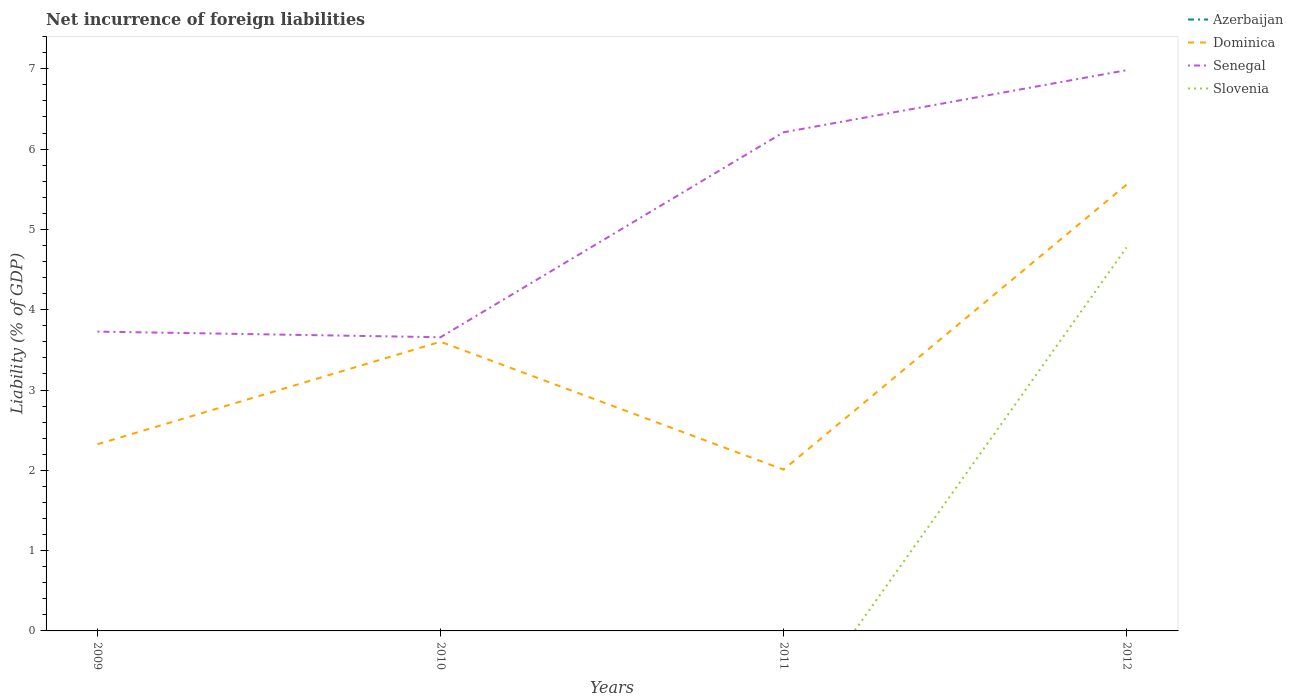Across all years, what is the maximum net incurrence of foreign liabilities in Senegal?
Ensure brevity in your answer.  3.66. What is the total net incurrence of foreign liabilities in Senegal in the graph?
Give a very brief answer. -2.55. What is the difference between the highest and the second highest net incurrence of foreign liabilities in Dominica?
Offer a terse response. 3.55. What is the difference between the highest and the lowest net incurrence of foreign liabilities in Azerbaijan?
Keep it short and to the point. 0. How many years are there in the graph?
Your answer should be very brief. 4. What is the difference between two consecutive major ticks on the Y-axis?
Provide a short and direct response. 1. Are the values on the major ticks of Y-axis written in scientific E-notation?
Ensure brevity in your answer.  No. Does the graph contain grids?
Make the answer very short. No. What is the title of the graph?
Ensure brevity in your answer.  Net incurrence of foreign liabilities. What is the label or title of the Y-axis?
Give a very brief answer. Liability (% of GDP). What is the Liability (% of GDP) in Azerbaijan in 2009?
Offer a very short reply. 0. What is the Liability (% of GDP) in Dominica in 2009?
Provide a succinct answer. 2.32. What is the Liability (% of GDP) in Senegal in 2009?
Provide a short and direct response. 3.73. What is the Liability (% of GDP) of Slovenia in 2009?
Offer a very short reply. 0. What is the Liability (% of GDP) of Dominica in 2010?
Keep it short and to the point. 3.6. What is the Liability (% of GDP) of Senegal in 2010?
Offer a terse response. 3.66. What is the Liability (% of GDP) of Azerbaijan in 2011?
Offer a terse response. 0. What is the Liability (% of GDP) in Dominica in 2011?
Provide a succinct answer. 2.01. What is the Liability (% of GDP) of Senegal in 2011?
Offer a very short reply. 6.21. What is the Liability (% of GDP) in Slovenia in 2011?
Provide a succinct answer. 0. What is the Liability (% of GDP) in Dominica in 2012?
Provide a succinct answer. 5.56. What is the Liability (% of GDP) in Senegal in 2012?
Your answer should be compact. 6.98. What is the Liability (% of GDP) in Slovenia in 2012?
Give a very brief answer. 4.78. Across all years, what is the maximum Liability (% of GDP) in Dominica?
Ensure brevity in your answer.  5.56. Across all years, what is the maximum Liability (% of GDP) of Senegal?
Provide a succinct answer. 6.98. Across all years, what is the maximum Liability (% of GDP) in Slovenia?
Give a very brief answer. 4.78. Across all years, what is the minimum Liability (% of GDP) in Dominica?
Give a very brief answer. 2.01. Across all years, what is the minimum Liability (% of GDP) in Senegal?
Your response must be concise. 3.66. Across all years, what is the minimum Liability (% of GDP) in Slovenia?
Keep it short and to the point. 0. What is the total Liability (% of GDP) in Azerbaijan in the graph?
Your response must be concise. 0. What is the total Liability (% of GDP) of Dominica in the graph?
Your answer should be very brief. 13.49. What is the total Liability (% of GDP) of Senegal in the graph?
Provide a succinct answer. 20.58. What is the total Liability (% of GDP) of Slovenia in the graph?
Your response must be concise. 4.78. What is the difference between the Liability (% of GDP) in Dominica in 2009 and that in 2010?
Your answer should be compact. -1.28. What is the difference between the Liability (% of GDP) in Senegal in 2009 and that in 2010?
Offer a terse response. 0.07. What is the difference between the Liability (% of GDP) of Dominica in 2009 and that in 2011?
Your answer should be compact. 0.32. What is the difference between the Liability (% of GDP) of Senegal in 2009 and that in 2011?
Provide a short and direct response. -2.48. What is the difference between the Liability (% of GDP) in Dominica in 2009 and that in 2012?
Offer a very short reply. -3.23. What is the difference between the Liability (% of GDP) in Senegal in 2009 and that in 2012?
Your answer should be compact. -3.26. What is the difference between the Liability (% of GDP) of Dominica in 2010 and that in 2011?
Your response must be concise. 1.59. What is the difference between the Liability (% of GDP) of Senegal in 2010 and that in 2011?
Provide a succinct answer. -2.55. What is the difference between the Liability (% of GDP) in Dominica in 2010 and that in 2012?
Keep it short and to the point. -1.96. What is the difference between the Liability (% of GDP) of Senegal in 2010 and that in 2012?
Your response must be concise. -3.33. What is the difference between the Liability (% of GDP) of Dominica in 2011 and that in 2012?
Provide a short and direct response. -3.55. What is the difference between the Liability (% of GDP) of Senegal in 2011 and that in 2012?
Offer a terse response. -0.77. What is the difference between the Liability (% of GDP) in Dominica in 2009 and the Liability (% of GDP) in Senegal in 2010?
Your response must be concise. -1.33. What is the difference between the Liability (% of GDP) in Dominica in 2009 and the Liability (% of GDP) in Senegal in 2011?
Offer a very short reply. -3.89. What is the difference between the Liability (% of GDP) in Dominica in 2009 and the Liability (% of GDP) in Senegal in 2012?
Your answer should be compact. -4.66. What is the difference between the Liability (% of GDP) in Dominica in 2009 and the Liability (% of GDP) in Slovenia in 2012?
Keep it short and to the point. -2.45. What is the difference between the Liability (% of GDP) of Senegal in 2009 and the Liability (% of GDP) of Slovenia in 2012?
Provide a succinct answer. -1.05. What is the difference between the Liability (% of GDP) in Dominica in 2010 and the Liability (% of GDP) in Senegal in 2011?
Your response must be concise. -2.61. What is the difference between the Liability (% of GDP) in Dominica in 2010 and the Liability (% of GDP) in Senegal in 2012?
Offer a very short reply. -3.38. What is the difference between the Liability (% of GDP) in Dominica in 2010 and the Liability (% of GDP) in Slovenia in 2012?
Keep it short and to the point. -1.17. What is the difference between the Liability (% of GDP) in Senegal in 2010 and the Liability (% of GDP) in Slovenia in 2012?
Make the answer very short. -1.12. What is the difference between the Liability (% of GDP) of Dominica in 2011 and the Liability (% of GDP) of Senegal in 2012?
Keep it short and to the point. -4.97. What is the difference between the Liability (% of GDP) of Dominica in 2011 and the Liability (% of GDP) of Slovenia in 2012?
Give a very brief answer. -2.77. What is the difference between the Liability (% of GDP) of Senegal in 2011 and the Liability (% of GDP) of Slovenia in 2012?
Offer a very short reply. 1.43. What is the average Liability (% of GDP) of Dominica per year?
Make the answer very short. 3.37. What is the average Liability (% of GDP) in Senegal per year?
Provide a short and direct response. 5.14. What is the average Liability (% of GDP) in Slovenia per year?
Offer a terse response. 1.19. In the year 2009, what is the difference between the Liability (% of GDP) in Dominica and Liability (% of GDP) in Senegal?
Make the answer very short. -1.4. In the year 2010, what is the difference between the Liability (% of GDP) of Dominica and Liability (% of GDP) of Senegal?
Ensure brevity in your answer.  -0.06. In the year 2011, what is the difference between the Liability (% of GDP) of Dominica and Liability (% of GDP) of Senegal?
Offer a terse response. -4.2. In the year 2012, what is the difference between the Liability (% of GDP) in Dominica and Liability (% of GDP) in Senegal?
Make the answer very short. -1.43. In the year 2012, what is the difference between the Liability (% of GDP) of Dominica and Liability (% of GDP) of Slovenia?
Provide a short and direct response. 0.78. In the year 2012, what is the difference between the Liability (% of GDP) in Senegal and Liability (% of GDP) in Slovenia?
Keep it short and to the point. 2.21. What is the ratio of the Liability (% of GDP) of Dominica in 2009 to that in 2010?
Make the answer very short. 0.65. What is the ratio of the Liability (% of GDP) in Senegal in 2009 to that in 2010?
Make the answer very short. 1.02. What is the ratio of the Liability (% of GDP) in Dominica in 2009 to that in 2011?
Your answer should be very brief. 1.16. What is the ratio of the Liability (% of GDP) of Senegal in 2009 to that in 2011?
Offer a terse response. 0.6. What is the ratio of the Liability (% of GDP) of Dominica in 2009 to that in 2012?
Offer a very short reply. 0.42. What is the ratio of the Liability (% of GDP) in Senegal in 2009 to that in 2012?
Offer a very short reply. 0.53. What is the ratio of the Liability (% of GDP) in Dominica in 2010 to that in 2011?
Ensure brevity in your answer.  1.79. What is the ratio of the Liability (% of GDP) of Senegal in 2010 to that in 2011?
Your response must be concise. 0.59. What is the ratio of the Liability (% of GDP) of Dominica in 2010 to that in 2012?
Provide a succinct answer. 0.65. What is the ratio of the Liability (% of GDP) of Senegal in 2010 to that in 2012?
Provide a short and direct response. 0.52. What is the ratio of the Liability (% of GDP) of Dominica in 2011 to that in 2012?
Your response must be concise. 0.36. What is the ratio of the Liability (% of GDP) of Senegal in 2011 to that in 2012?
Your answer should be compact. 0.89. What is the difference between the highest and the second highest Liability (% of GDP) in Dominica?
Offer a very short reply. 1.96. What is the difference between the highest and the second highest Liability (% of GDP) of Senegal?
Offer a terse response. 0.77. What is the difference between the highest and the lowest Liability (% of GDP) in Dominica?
Make the answer very short. 3.55. What is the difference between the highest and the lowest Liability (% of GDP) in Senegal?
Keep it short and to the point. 3.33. What is the difference between the highest and the lowest Liability (% of GDP) of Slovenia?
Offer a terse response. 4.78. 